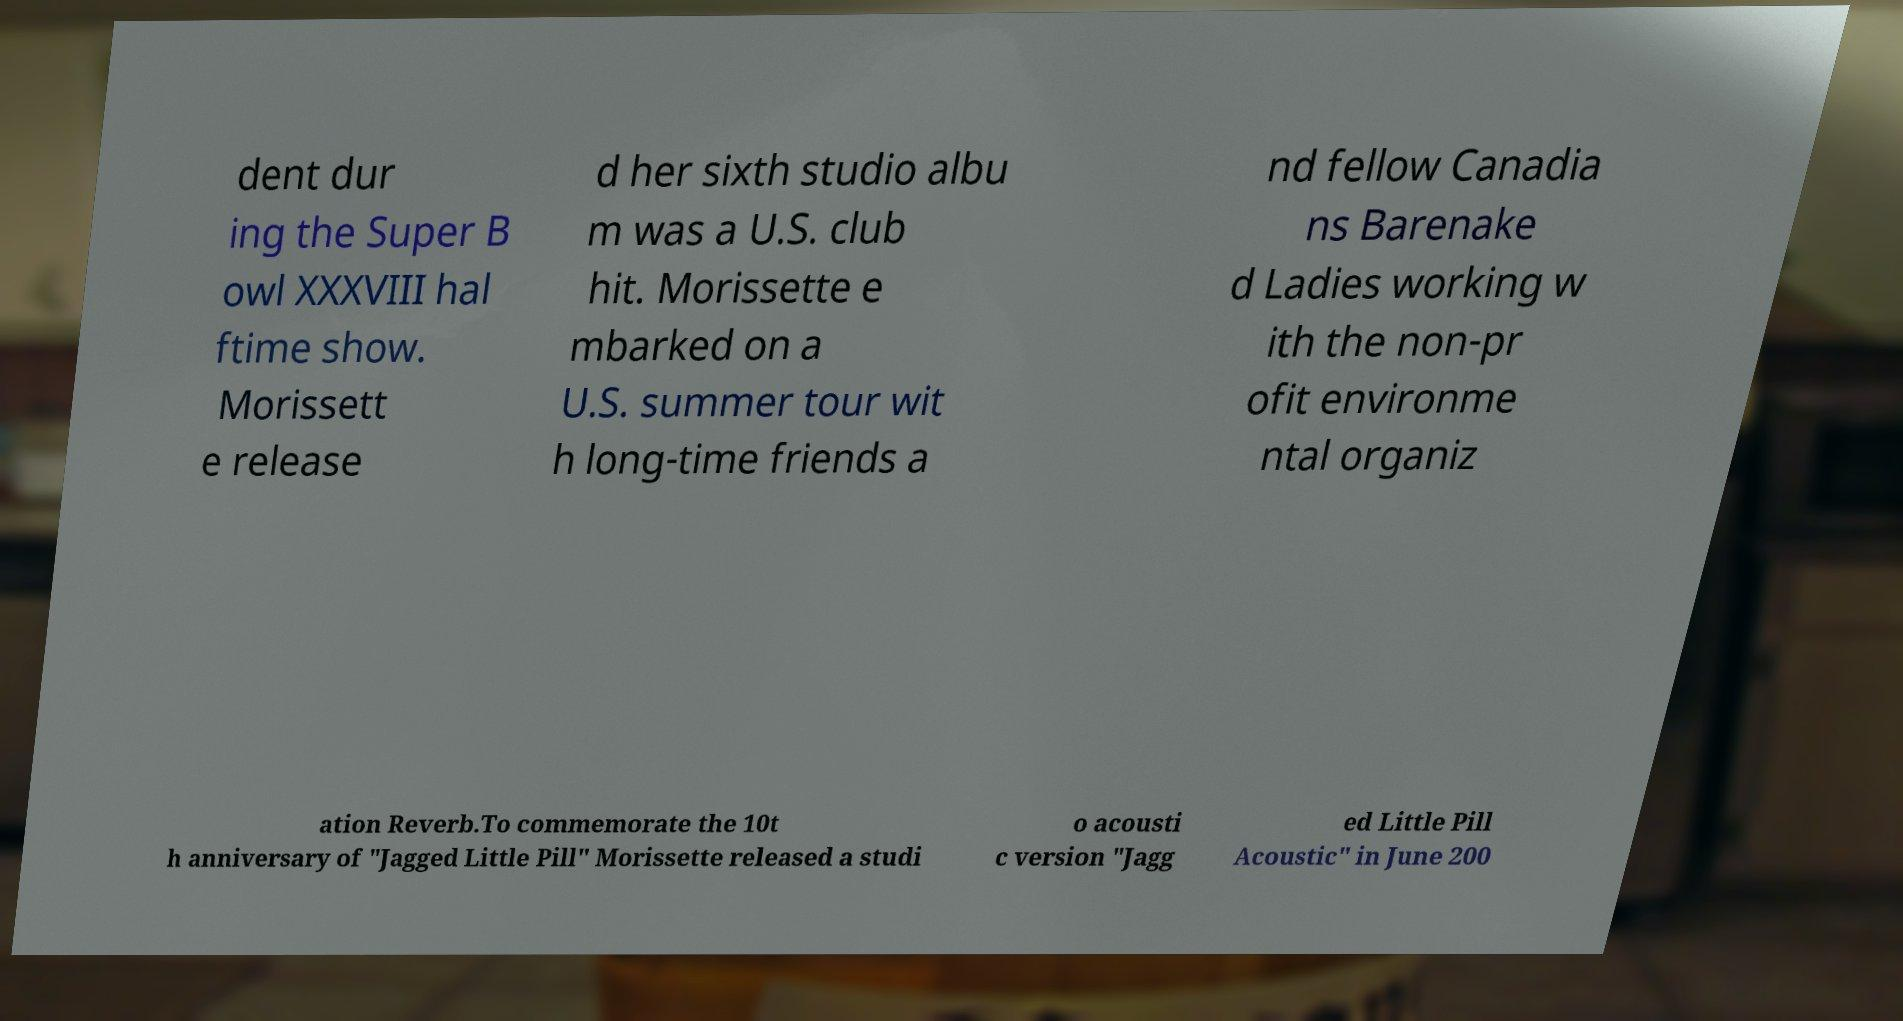Could you assist in decoding the text presented in this image and type it out clearly? dent dur ing the Super B owl XXXVIII hal ftime show. Morissett e release d her sixth studio albu m was a U.S. club hit. Morissette e mbarked on a U.S. summer tour wit h long-time friends a nd fellow Canadia ns Barenake d Ladies working w ith the non-pr ofit environme ntal organiz ation Reverb.To commemorate the 10t h anniversary of "Jagged Little Pill" Morissette released a studi o acousti c version "Jagg ed Little Pill Acoustic" in June 200 